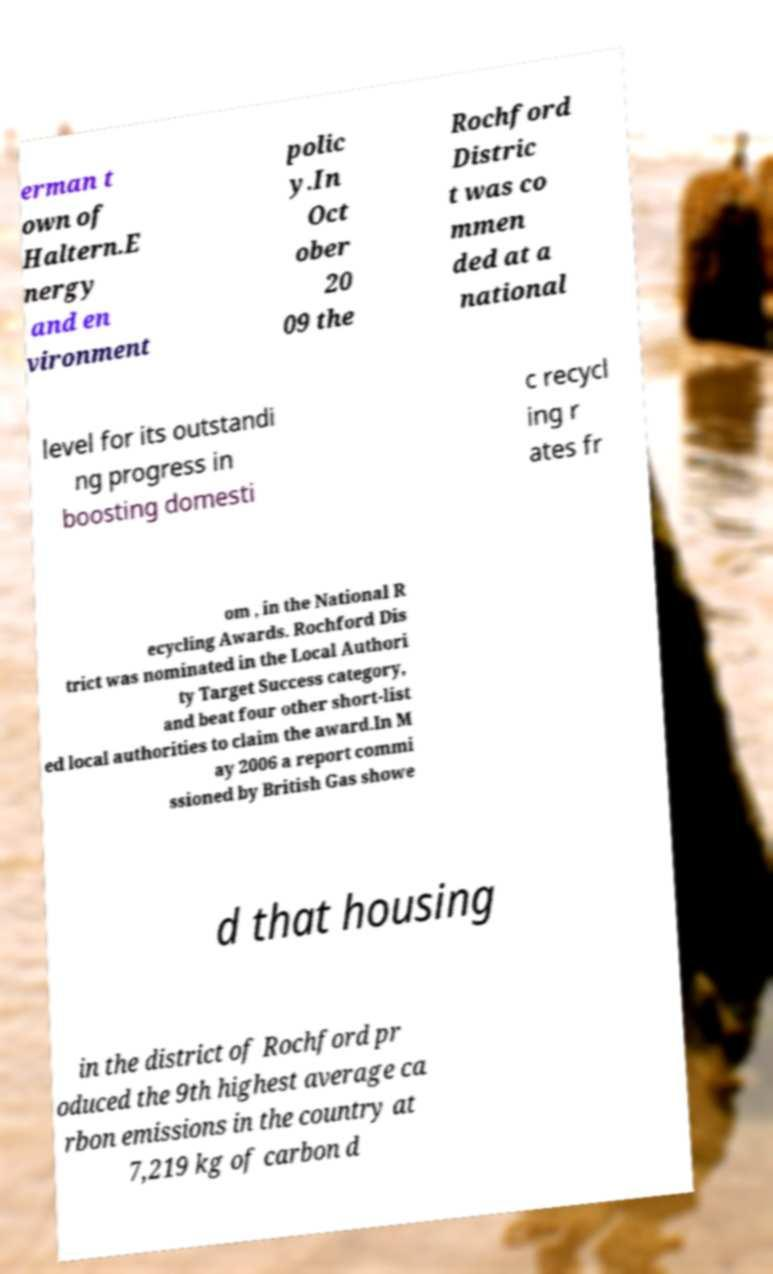I need the written content from this picture converted into text. Can you do that? erman t own of Haltern.E nergy and en vironment polic y.In Oct ober 20 09 the Rochford Distric t was co mmen ded at a national level for its outstandi ng progress in boosting domesti c recycl ing r ates fr om , in the National R ecycling Awards. Rochford Dis trict was nominated in the Local Authori ty Target Success category, and beat four other short-list ed local authorities to claim the award.In M ay 2006 a report commi ssioned by British Gas showe d that housing in the district of Rochford pr oduced the 9th highest average ca rbon emissions in the country at 7,219 kg of carbon d 